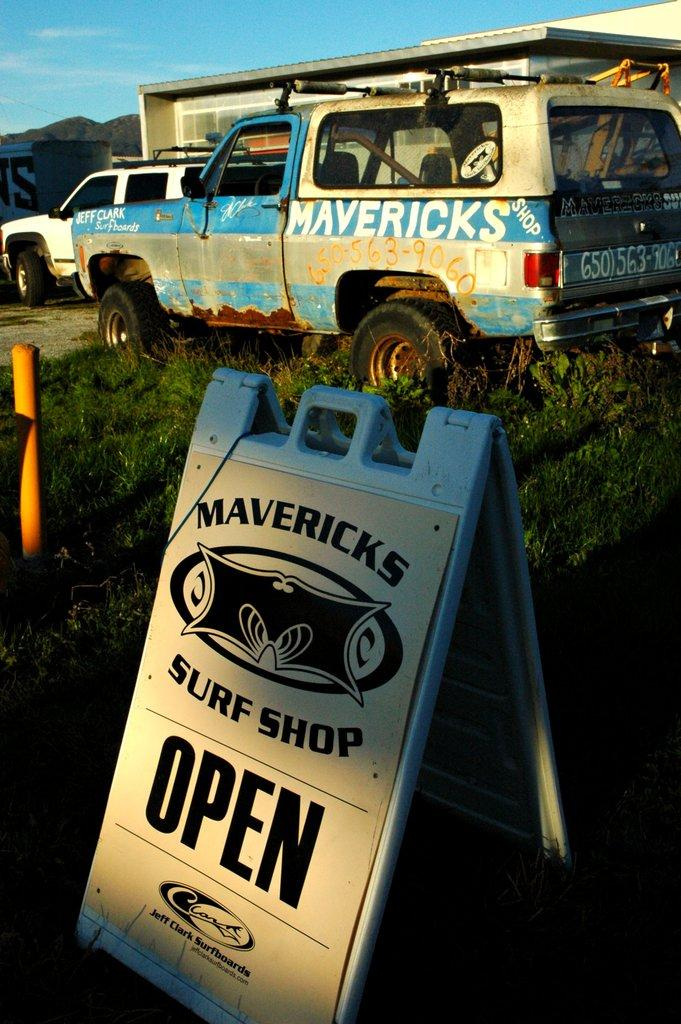What type of establishment is shown in the image? The image depicts a mechanic shop. Can you describe the condition of one of the vehicles in the image? There is a damaged vehicle in the image. What is the condition of the other vehicle in the image? There is a good vehicle parked in front of the store. Where is the damaged vehicle located in the image? The damaged vehicle is on the grass. What type of invention can be seen flying over the mechanic shop in the image? There is no invention or object flying over the mechanic shop in the image. Can you describe the type of tank that is parked next to the damaged vehicle in the image? There is no tank present in the image; it only features a damaged vehicle and a good vehicle parked in front of the store. 